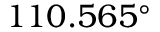Convert formula to latex. <formula><loc_0><loc_0><loc_500><loc_500>1 1 0 . 5 6 5 ^ { \circ }</formula> 